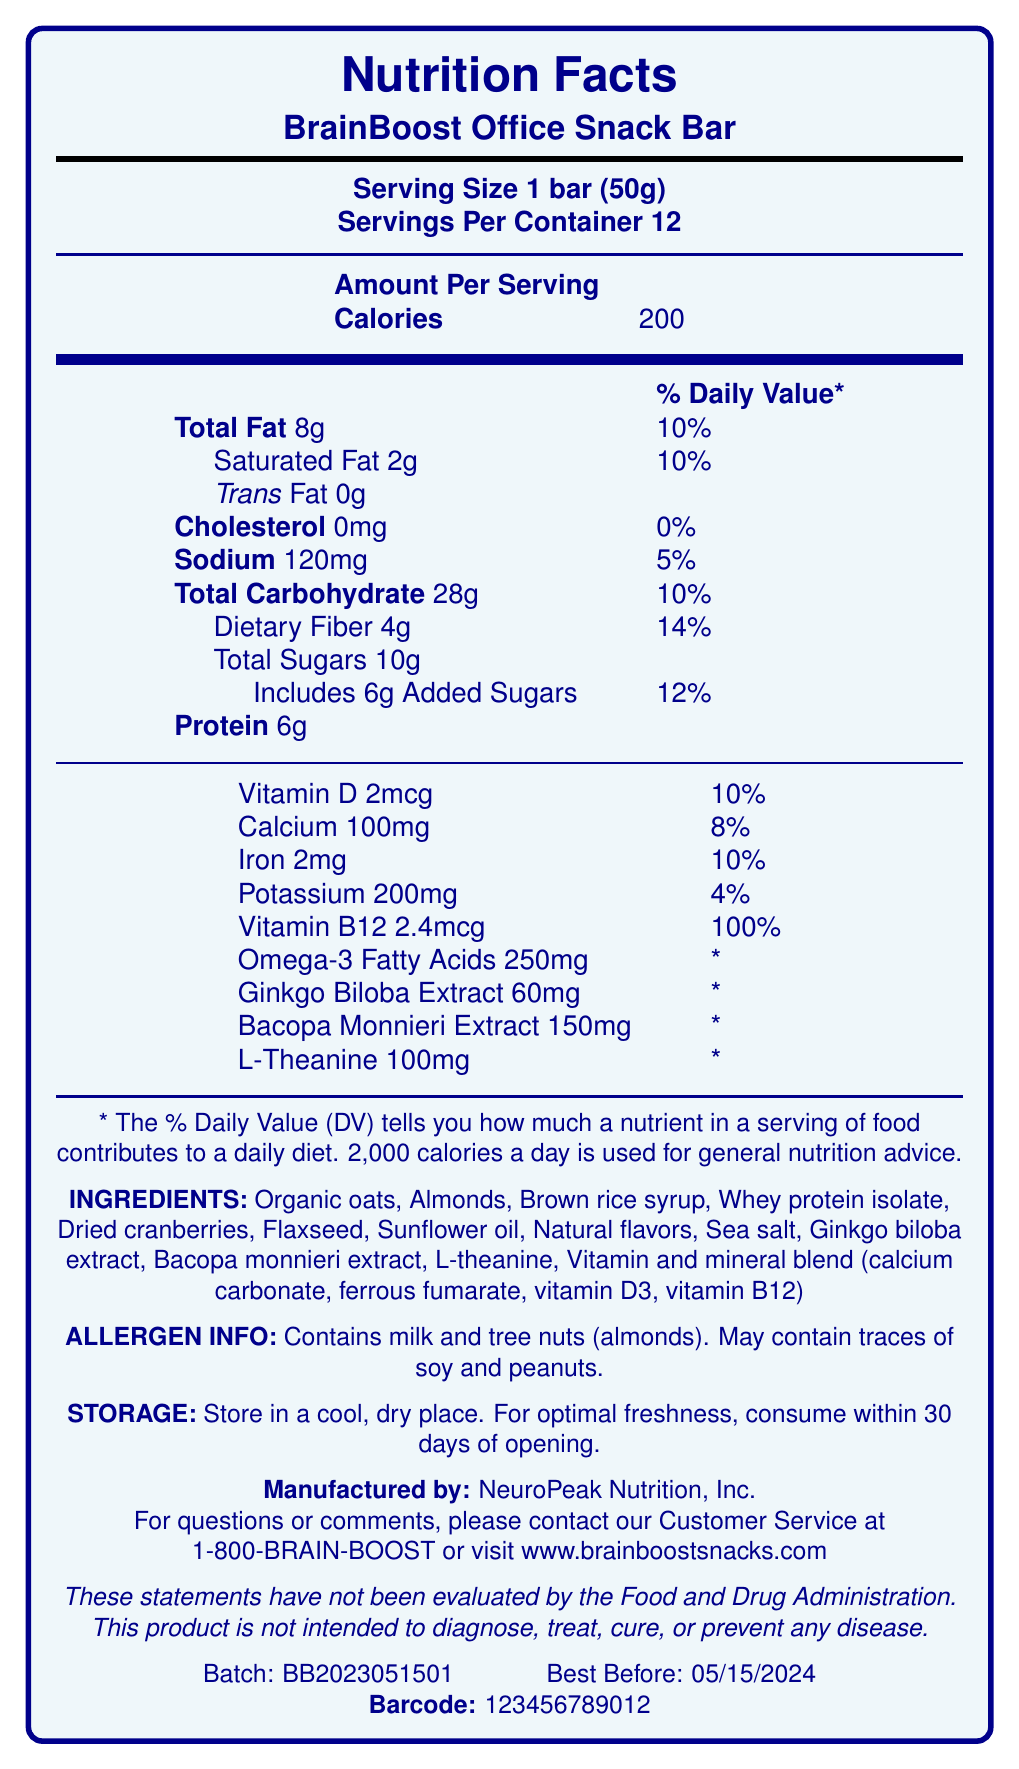what is the serving size for BrainBoost Office Snack Bar? The serving size is explicitly mentioned as "1 bar (50g)" in the document.
Answer: 1 bar (50g) how many servings are there per container? The document states that there are 12 servings per container.
Answer: 12 how many calories are in one serving of the BrainBoost Office Snack Bar? The amount per serving for calories is listed as 200.
Answer: 200 what is the total amount of fat in one serving? The document lists the total amount of fat as 8g.
Answer: 8g what is the daily value percentage for saturated fat in one serving? The daily value percentage for saturated fat is given as 10%.
Answer: 10% how much dietary fiber does one bar contain? The document specifies that one bar contains 4g of dietary fiber.
Answer: 4g A. Vitamin D B. Calcium C. Iron D. Potassium E. Vitamin B12 The document lists Vitamin B12 as having a daily value of 100%, which is the highest among the options.
Answer: E which of the following extracts is NOT included in the BrainBoost Office Snack Bar? 1. Ginkgo Biloba 2. Bacopa Monnieri 3. Garlic Extract 4. L-Theanine The ingredient list includes Ginkgo Biloba, Bacopa Monnieri, and L-Theanine, but not Garlic Extract.
Answer: 3 does the product contain any allergens? The allergen info section states that the product contains milk and tree nuts (almonds) and may contain traces of soy and peanuts.
Answer: Yes summarize the main idea of the Nutrition Facts Label for the BrainBoost Office Snack Bar. The document provides detailed nutrition facts, ingredients, allergen information, storage instructions, and manufacturing details about the BrainBoost Office Snack Bar.
Answer: The BrainBoost Office Snack Bar is a fortified snack designed to support cognitive function. Each bar serves as one serving size (50g) and contains 200 calories, 8g of total fat, and a variety of vitamins and minerals. It includes special ingredients like Ginkgo Biloba Extract, Bacopa Monnieri Extract, and L-Theanine. It contains milk and tree nuts and should be stored in a cool, dry place. Manufactured by NeuroPeak Nutrition, Inc., the product has a best-before date of 05/15/2024. when should you consume the product by for optimal freshness? The storage instructions recommend consuming it within 30 days of opening for optimal freshness.
Answer: Within 30 days of opening what is the amount of sodium in one serving? The amount of sodium per serving is listed as 120mg.
Answer: 120mg how much iron is provided in each serving, and what percentage of the daily value does it represent? Each serving contains 2mg of iron, which represents 10% of the daily value.
Answer: 2mg, 10% is this product intended to diagnose, treat, cure, or prevent any disease? The disclaimer explicitly states that the product is not intended to diagnose, treat, cure, or prevent any disease.
Answer: No what is the contact number for customer service? The document lists the customer service contact number as 1-800-BRAIN-BOOST.
Answer: 1-800-BRAIN-BOOST who is the manufacturer of the BrainBoost Office Snack Bar? The document states that the manufacturer is NeuroPeak Nutrition, Inc.
Answer: NeuroPeak Nutrition, Inc. how much vitamin D does one serving provide? The document lists vitamin D content as 2mcg per serving.
Answer: 2mcg how much protein is in each bar? Each bar contains 6g of protein.
Answer: 6g does the document specify the source of the whey protein isolate used in the bar? The document mentions that whey protein isolate is an ingredient but does not specify its source.
Answer: Not enough information 